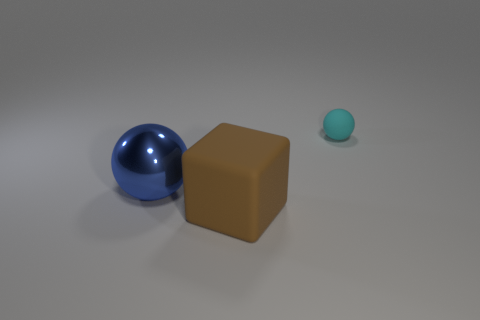If these objects were part of a game, what could be their potential roles or functions? If we imagine these objects as part of a game, the blue hemisphere could act as a player's piece, gliding smoothly across the board due to its curved surface. The brown cube might serve as an obstacle or a terrain feature to navigate around, and the tiny cyan object could represent a bonus item or goal – its small size and distinct color making it a notable target in the game's context. 